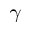<formula> <loc_0><loc_0><loc_500><loc_500>\gamma</formula> 